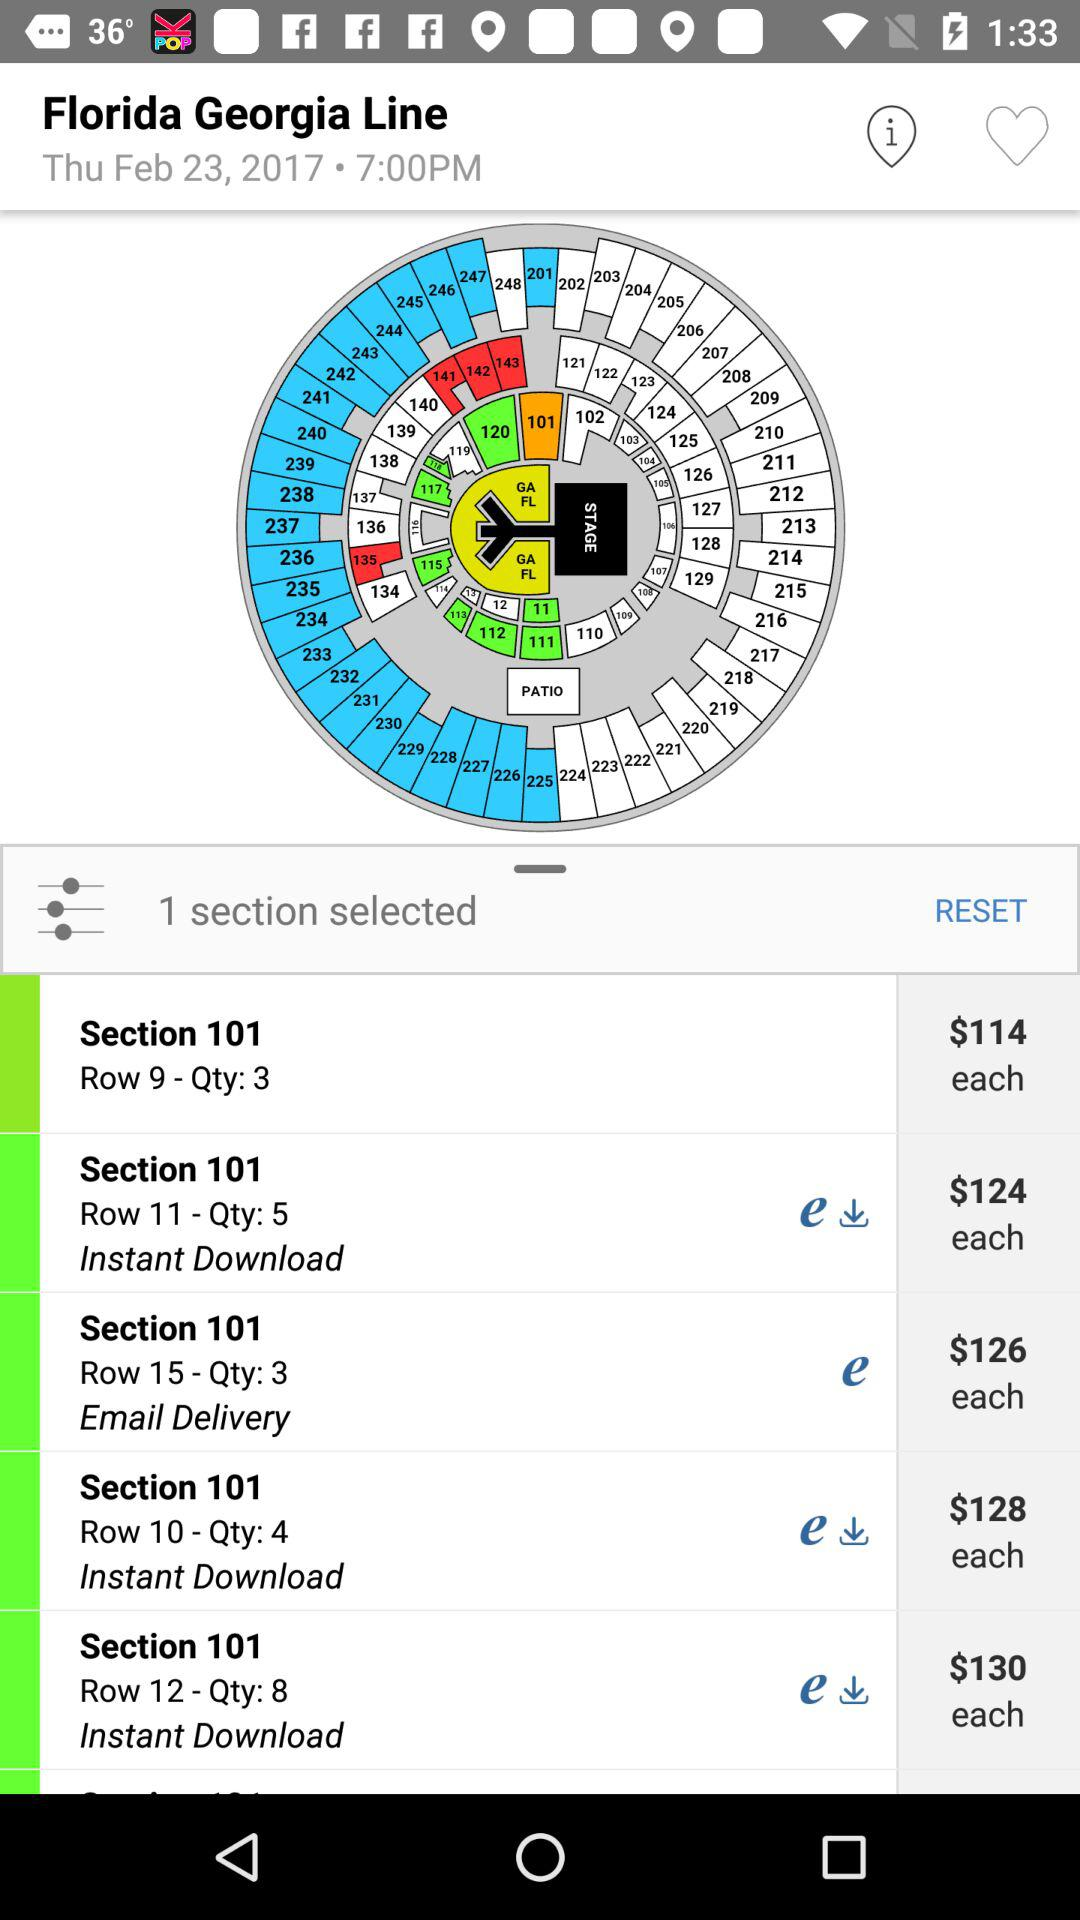How many sections are selected? The number of selected section is 1. 